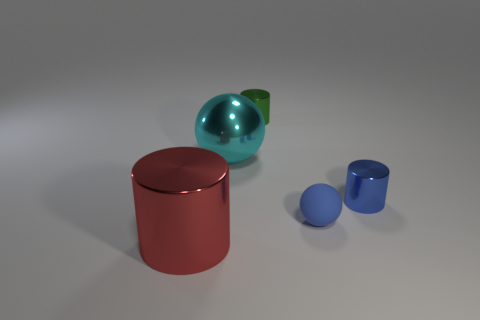Add 3 green matte blocks. How many objects exist? 8 Subtract all balls. How many objects are left? 3 Add 3 red metallic cylinders. How many red metallic cylinders are left? 4 Add 2 tiny purple cylinders. How many tiny purple cylinders exist? 2 Subtract 0 yellow spheres. How many objects are left? 5 Subtract all rubber cylinders. Subtract all cyan metallic objects. How many objects are left? 4 